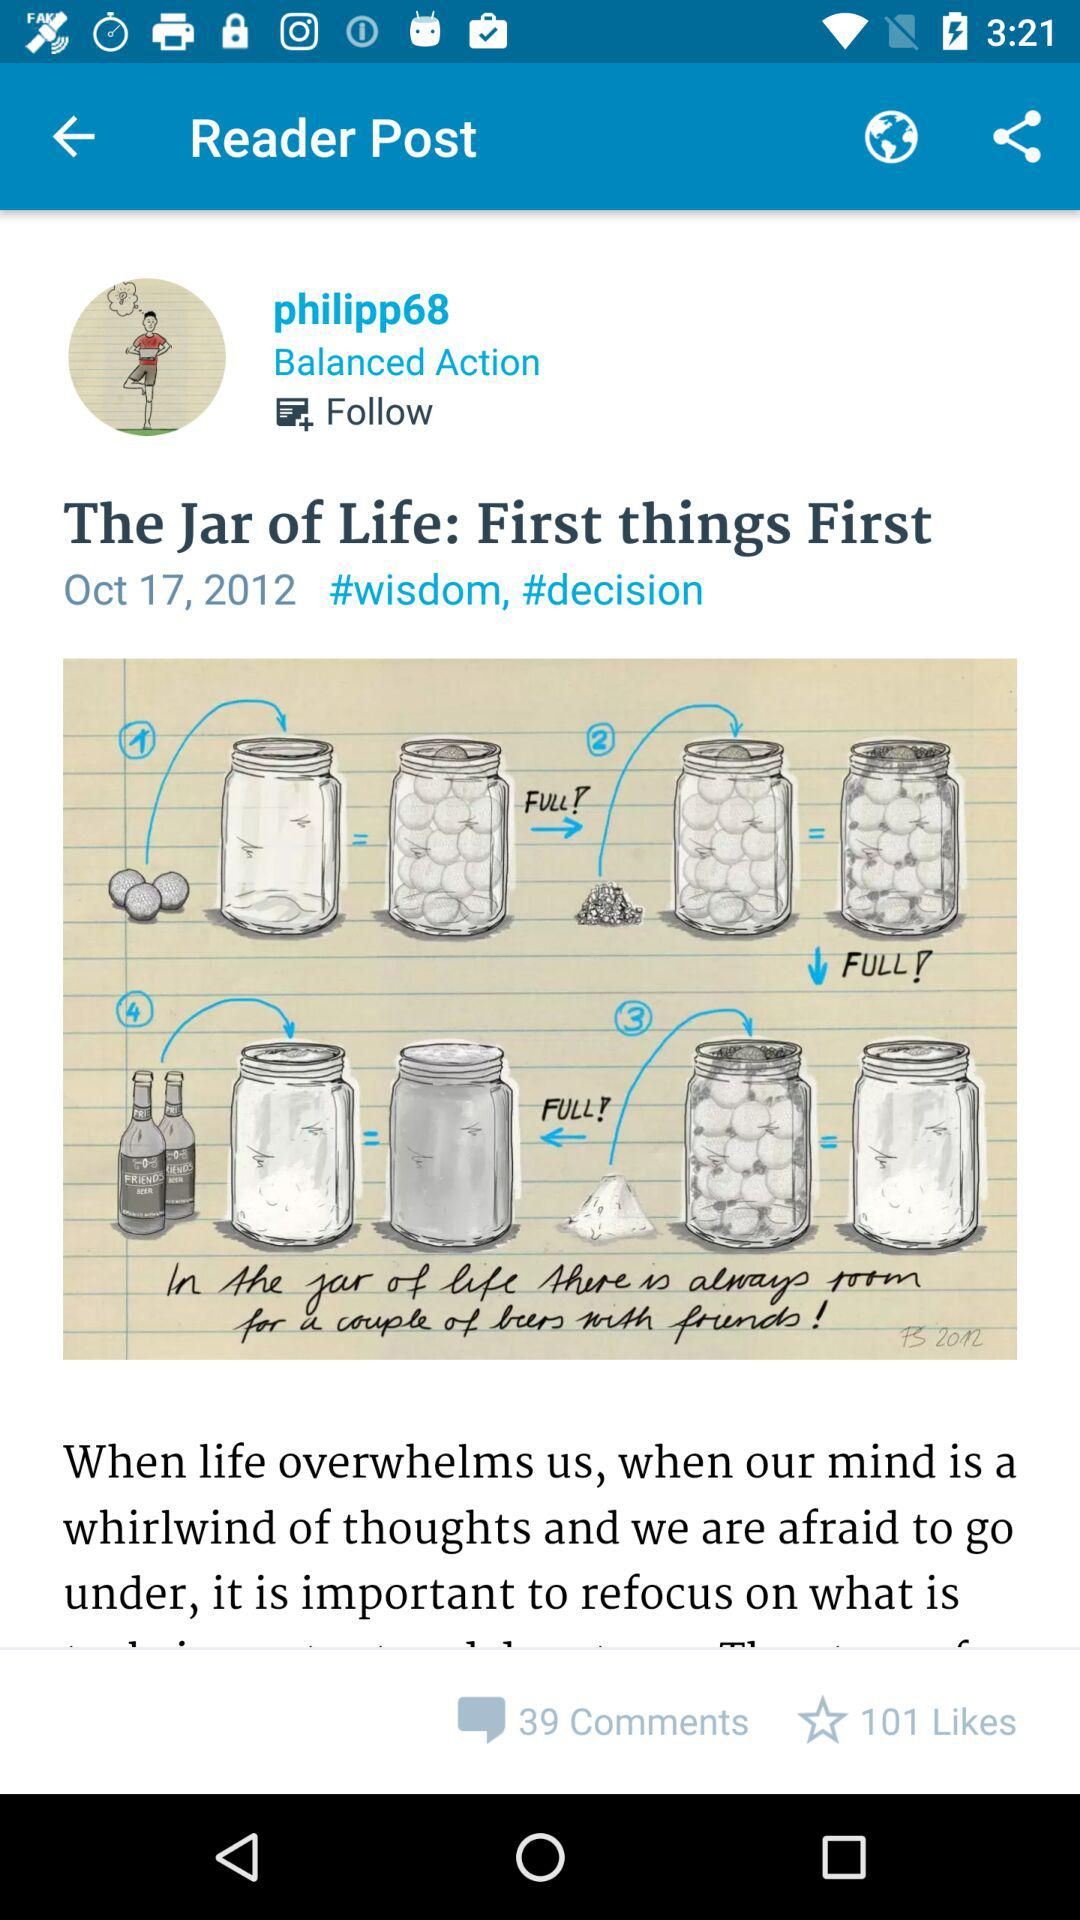What is the person's name? The person's name is "philipp68". 